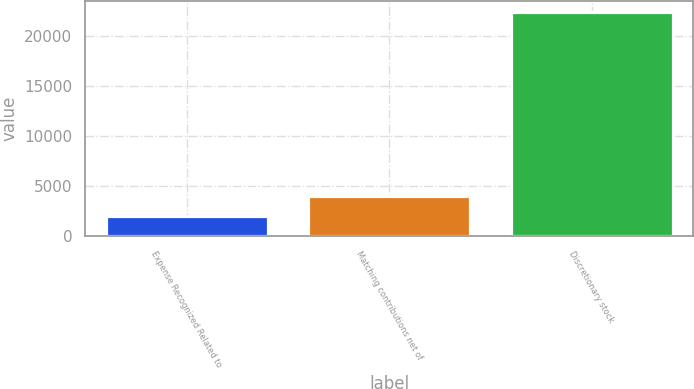Convert chart. <chart><loc_0><loc_0><loc_500><loc_500><bar_chart><fcel>Expense Recognized Related to<fcel>Matching contributions net of<fcel>Discretionary stock<nl><fcel>2011<fcel>4043<fcel>22331<nl></chart> 